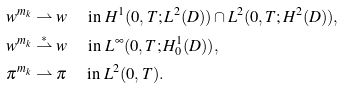Convert formula to latex. <formula><loc_0><loc_0><loc_500><loc_500>& w ^ { m _ { k } } \rightharpoonup w \quad \text { in   } H ^ { 1 } ( 0 , T ; L ^ { 2 } ( D ) ) \cap L ^ { 2 } ( 0 , T ; H ^ { 2 } ( D ) ) , \\ & w ^ { m _ { k } } \overset { * } { \rightharpoonup } w \quad \text { in   } L ^ { \infty } ( 0 , T ; H ^ { 1 } _ { 0 } ( D ) ) , \\ & \pi ^ { m _ { k } } \rightharpoonup \pi \quad \text { in } L ^ { 2 } ( 0 , T ) .</formula> 